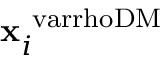<formula> <loc_0><loc_0><loc_500><loc_500>x _ { i } ^ { \ v a r r h o D M }</formula> 